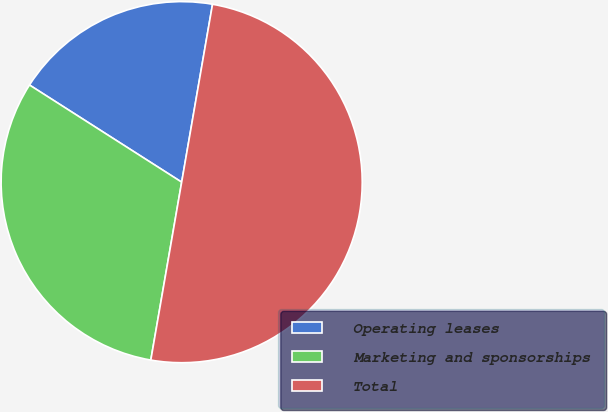<chart> <loc_0><loc_0><loc_500><loc_500><pie_chart><fcel>Operating leases<fcel>Marketing and sponsorships<fcel>Total<nl><fcel>18.69%<fcel>31.31%<fcel>50.0%<nl></chart> 